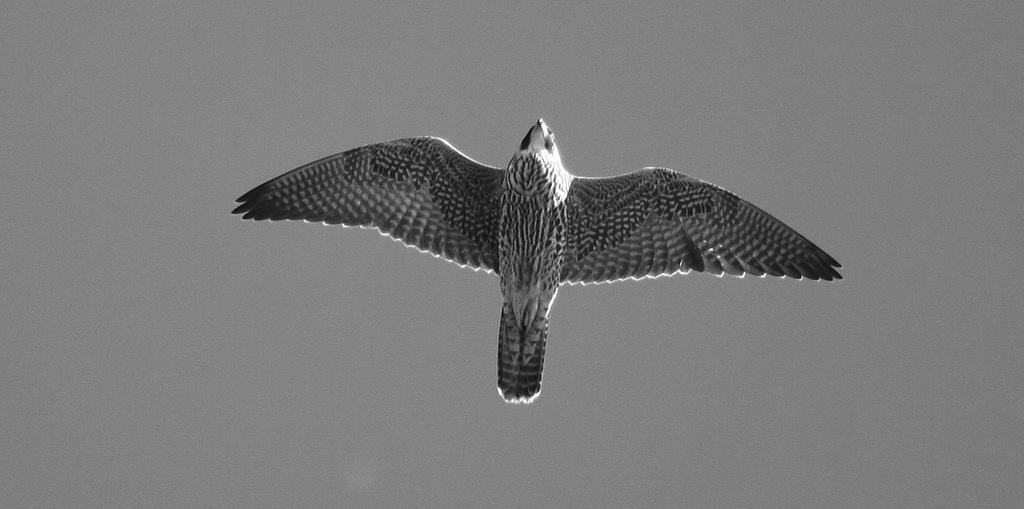What is the main subject of the image? There is a bird in the center of the image. Can you describe the bird's appearance? The bird is grey in color. What can be seen in the background of the image? The background of the image is grey. What type of can is visible in the image? There is no can present in the image; it features a grey bird against a grey background. What kind of linen is draped over the bird in the image? There is no linen present in the image; the bird is not covered by any fabric. 